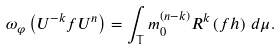<formula> <loc_0><loc_0><loc_500><loc_500>\omega _ { \varphi } \left ( U ^ { - k } f U ^ { n } \right ) = \int _ { \mathbb { T } } m _ { 0 } ^ { \left ( n - k \right ) } R ^ { k } \left ( f h \right ) \, d \mu .</formula> 